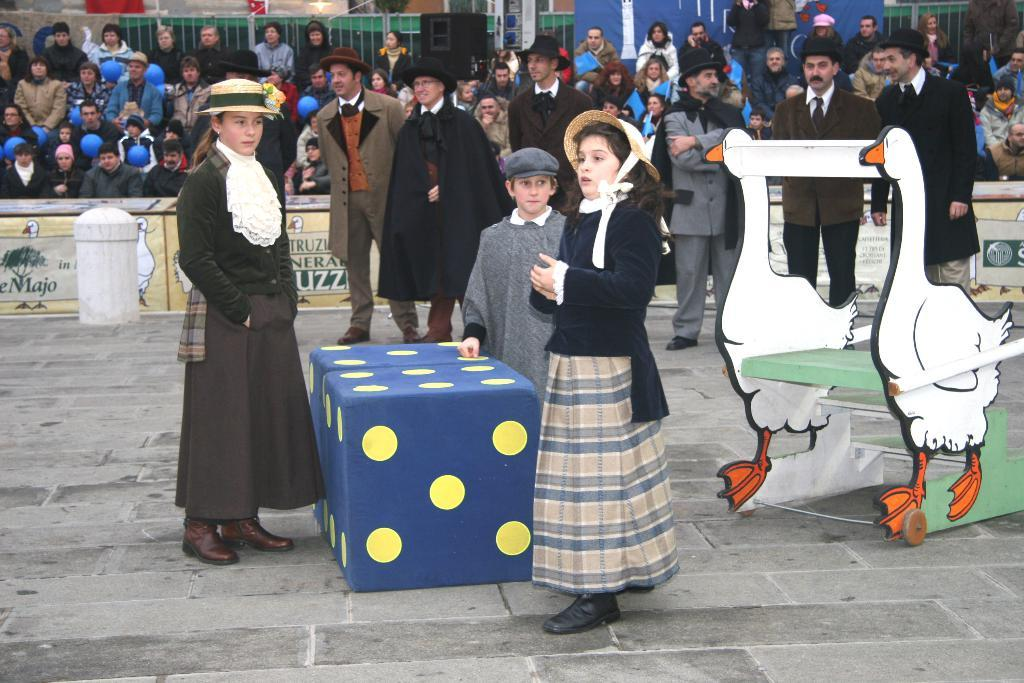What is happening in the image? There are people standing and sitting in the image. How are the people dressed? The people are wearing different color dresses. What objects can be seen in the image besides the people? There are blue and yellow boxes, a white pole, and a duck-shaped vehicle in the image. What type of card is being used to clean the soap in the image? There is no card or soap present in the image. What is the quiver used for in the image? There is no quiver present in the image. 